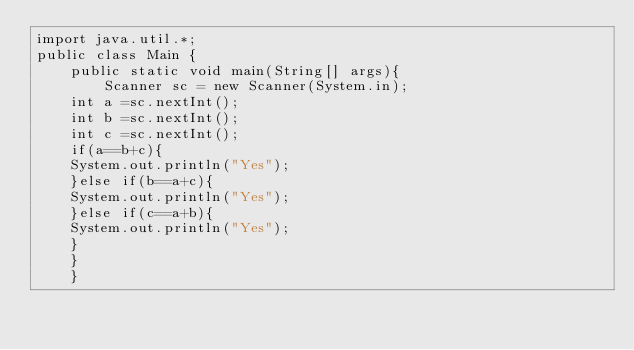<code> <loc_0><loc_0><loc_500><loc_500><_Java_>import java.util.*;
public class Main {
    public static void main(String[] args){
        Scanner sc = new Scanner(System.in);
	int a =sc.nextInt();
	int b =sc.nextInt();
	int c =sc.nextInt();
	if(a==b+c){
	System.out.println("Yes");
	}else if(b==a+c){
	System.out.println("Yes");
	}else if(c==a+b){
	System.out.println("Yes");
	}
	}
	}
</code> 